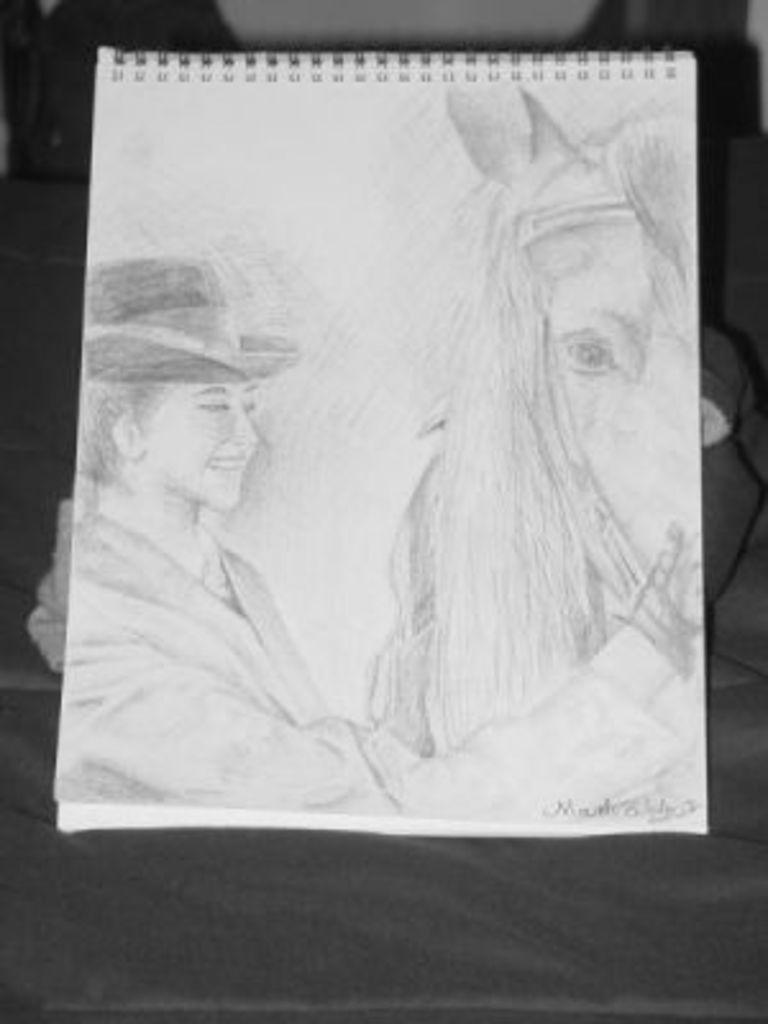Describe this image in one or two sentences. In this image I can see it looks like a sketch, on the left side there is a person touching the horse and also wearing the hat. On the right side there is the horse. 